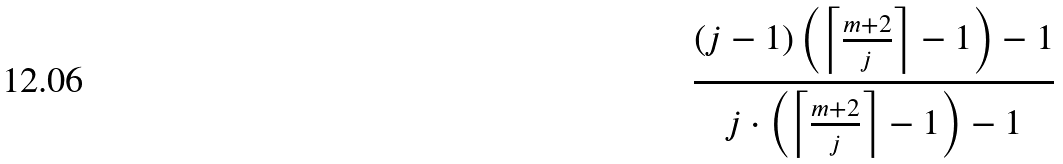<formula> <loc_0><loc_0><loc_500><loc_500>\frac { ( j - 1 ) \left ( \left \lceil \frac { m + 2 } { j } \right \rceil - 1 \right ) - 1 } { j \cdot \left ( \left \lceil \frac { m + 2 } { j } \right \rceil - 1 \right ) - 1 }</formula> 